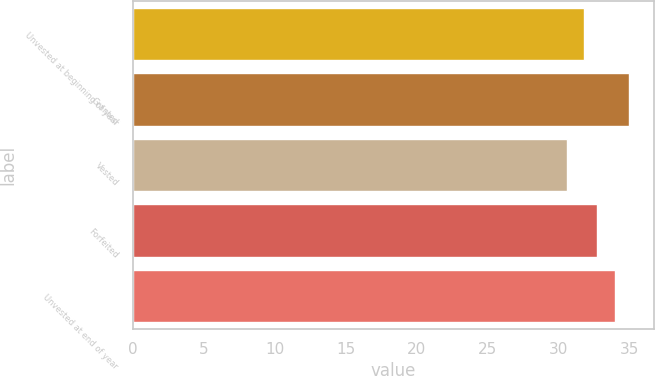Convert chart to OTSL. <chart><loc_0><loc_0><loc_500><loc_500><bar_chart><fcel>Unvested at beginning of year<fcel>Granted<fcel>Vested<fcel>Forfeited<fcel>Unvested at end of year<nl><fcel>31.8<fcel>34.98<fcel>30.64<fcel>32.73<fcel>34.04<nl></chart> 